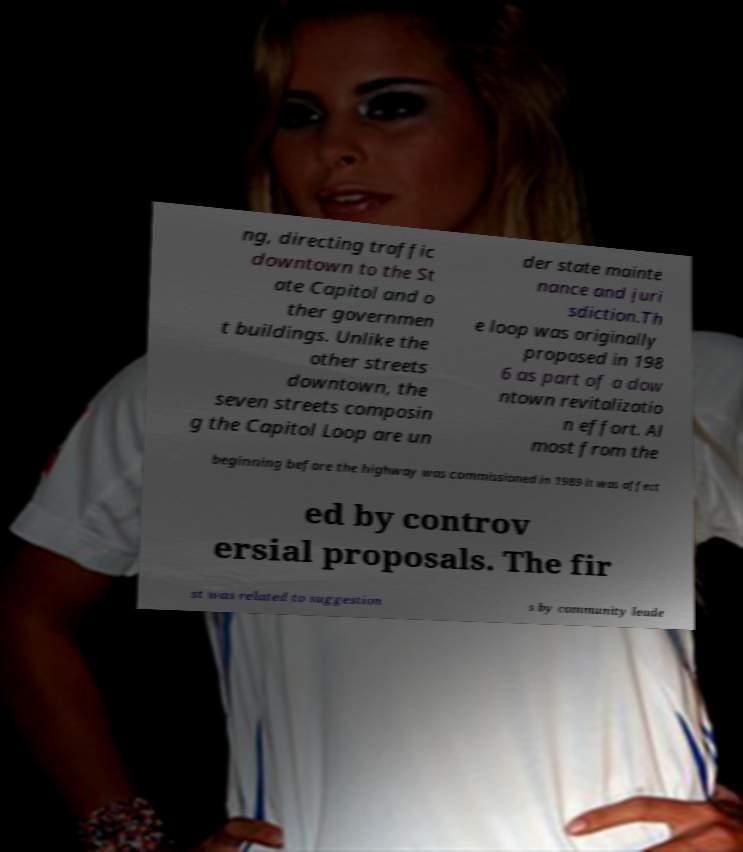Can you accurately transcribe the text from the provided image for me? ng, directing traffic downtown to the St ate Capitol and o ther governmen t buildings. Unlike the other streets downtown, the seven streets composin g the Capitol Loop are un der state mainte nance and juri sdiction.Th e loop was originally proposed in 198 6 as part of a dow ntown revitalizatio n effort. Al most from the beginning before the highway was commissioned in 1989 it was affect ed by controv ersial proposals. The fir st was related to suggestion s by community leade 